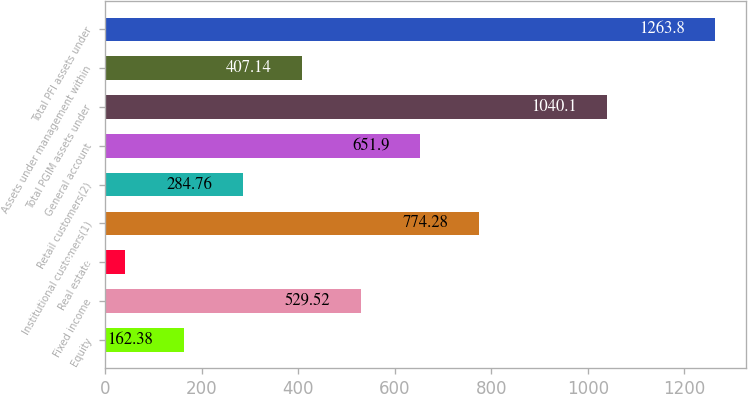Convert chart. <chart><loc_0><loc_0><loc_500><loc_500><bar_chart><fcel>Equity<fcel>Fixed income<fcel>Real estate<fcel>Institutional customers(1)<fcel>Retail customers(2)<fcel>General account<fcel>Total PGIM assets under<fcel>Assets under management within<fcel>Total PFI assets under<nl><fcel>162.38<fcel>529.52<fcel>40<fcel>774.28<fcel>284.76<fcel>651.9<fcel>1040.1<fcel>407.14<fcel>1263.8<nl></chart> 